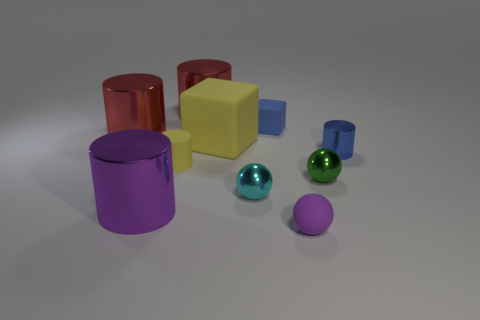Are there more cyan metallic things in front of the yellow matte cube than red cylinders in front of the tiny purple thing?
Make the answer very short. Yes. What number of other objects are there of the same shape as the small purple thing?
Ensure brevity in your answer.  2. There is a big cylinder that is to the right of the purple shiny cylinder; are there any things on the left side of it?
Ensure brevity in your answer.  Yes. How many matte blocks are there?
Your answer should be compact. 2. Does the matte cylinder have the same color as the block left of the tiny blue cube?
Provide a short and direct response. Yes. Are there more tiny gray rubber blocks than green spheres?
Provide a short and direct response. No. Are there any other things that have the same color as the rubber ball?
Your answer should be very brief. Yes. How many other things are there of the same size as the matte cylinder?
Provide a succinct answer. 5. There is a cylinder to the right of the shiny sphere behind the tiny metallic object that is to the left of the blue rubber cube; what is it made of?
Your response must be concise. Metal. Is the material of the purple sphere the same as the large red thing that is to the left of the small yellow thing?
Keep it short and to the point. No. 